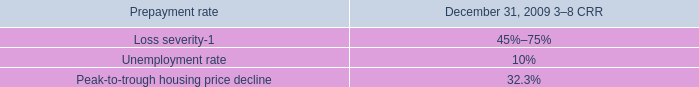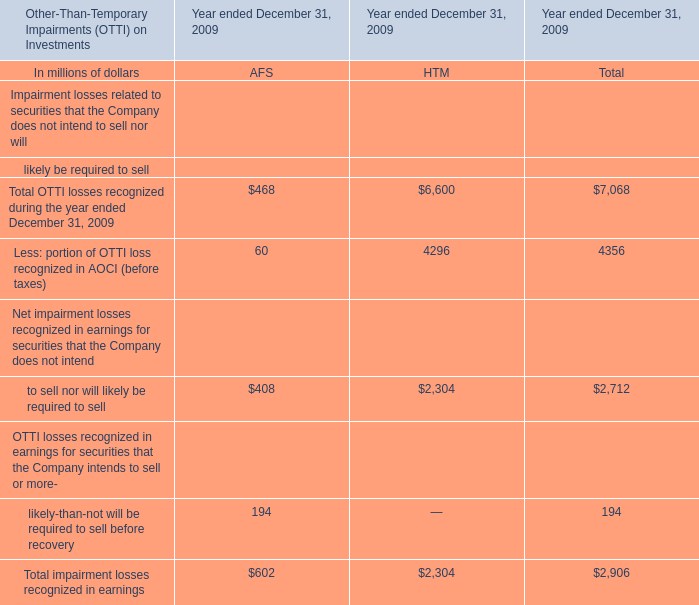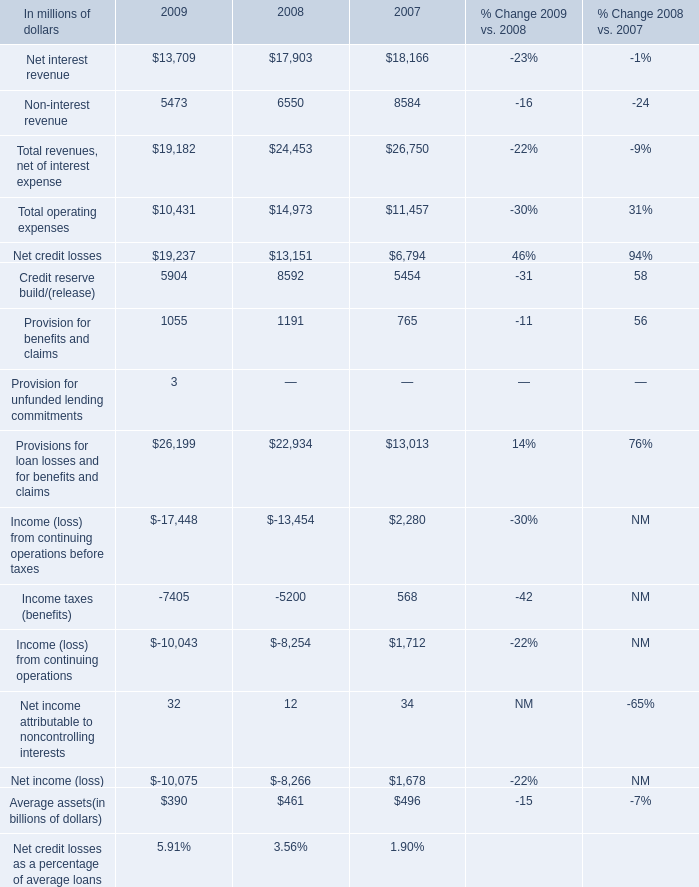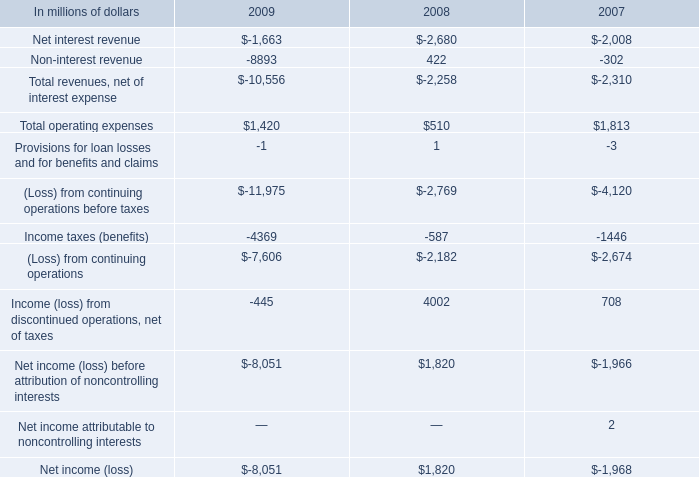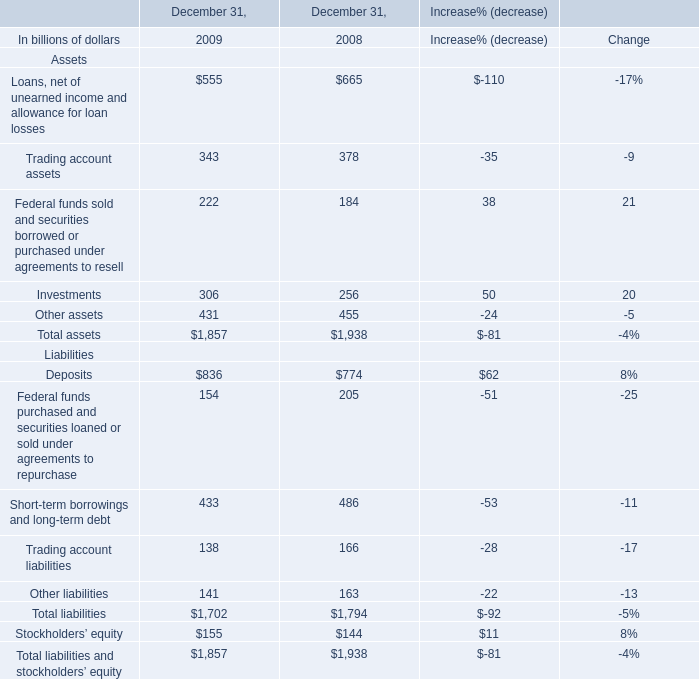In the year with largest amount of Net interest revenue, what's the sum of Non-interest revenue? (in millions) 
Answer: 6550. 